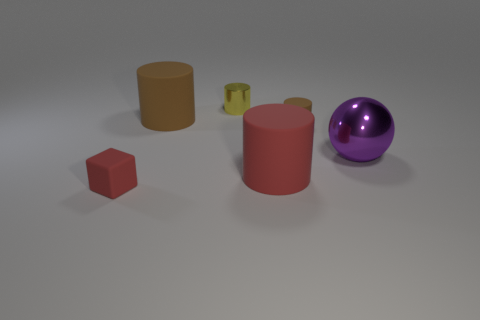Does the purple metallic thing have the same size as the yellow cylinder?
Provide a succinct answer. No. The matte object that is both behind the small block and in front of the purple ball is what color?
Your answer should be very brief. Red. The tiny thing that is the same material as the small brown cylinder is what shape?
Keep it short and to the point. Cube. How many things are right of the yellow thing and behind the red matte cylinder?
Provide a succinct answer. 2. Are there any large red matte objects to the left of the tiny rubber cube?
Offer a very short reply. No. There is a tiny matte object on the right side of the small red matte thing; is its shape the same as the red object behind the tiny red rubber thing?
Your answer should be compact. Yes. What number of objects are tiny brown matte spheres or brown objects that are to the left of the large red matte thing?
Make the answer very short. 1. How many other things are the same shape as the yellow object?
Your answer should be compact. 3. Is the material of the small object that is in front of the ball the same as the tiny yellow object?
Make the answer very short. No. What number of things are big brown shiny balls or rubber things?
Offer a very short reply. 4. 